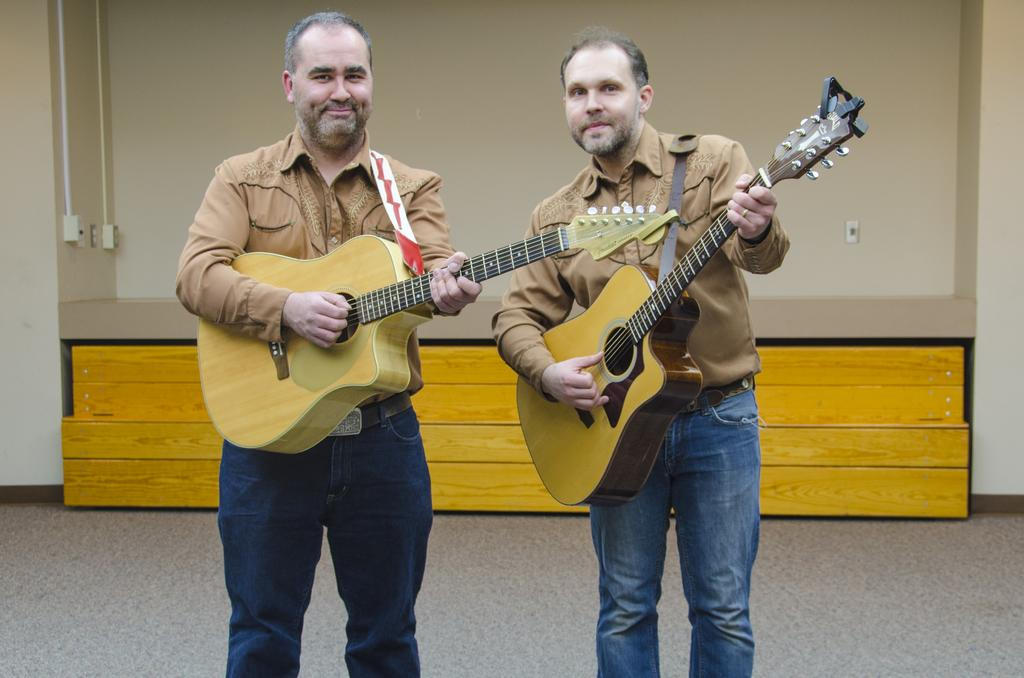What can be seen in the background of the image? There is a wall in the background of the image. How many people are in the image? There are two men in the image. What are the men doing in the image? The men are standing and playing guitars. What expressions do the men have on their faces? The men have smiles on their faces. What type of horse can be seen in the image? There is no horse present in the image. What unit of measurement is used to determine the size of the guitars in the image? The provided facts do not mention any specific unit of measurement for the guitars. How much was the payment for the men to play their guitars in the image? There is no information about payment in the image or the provided facts. 